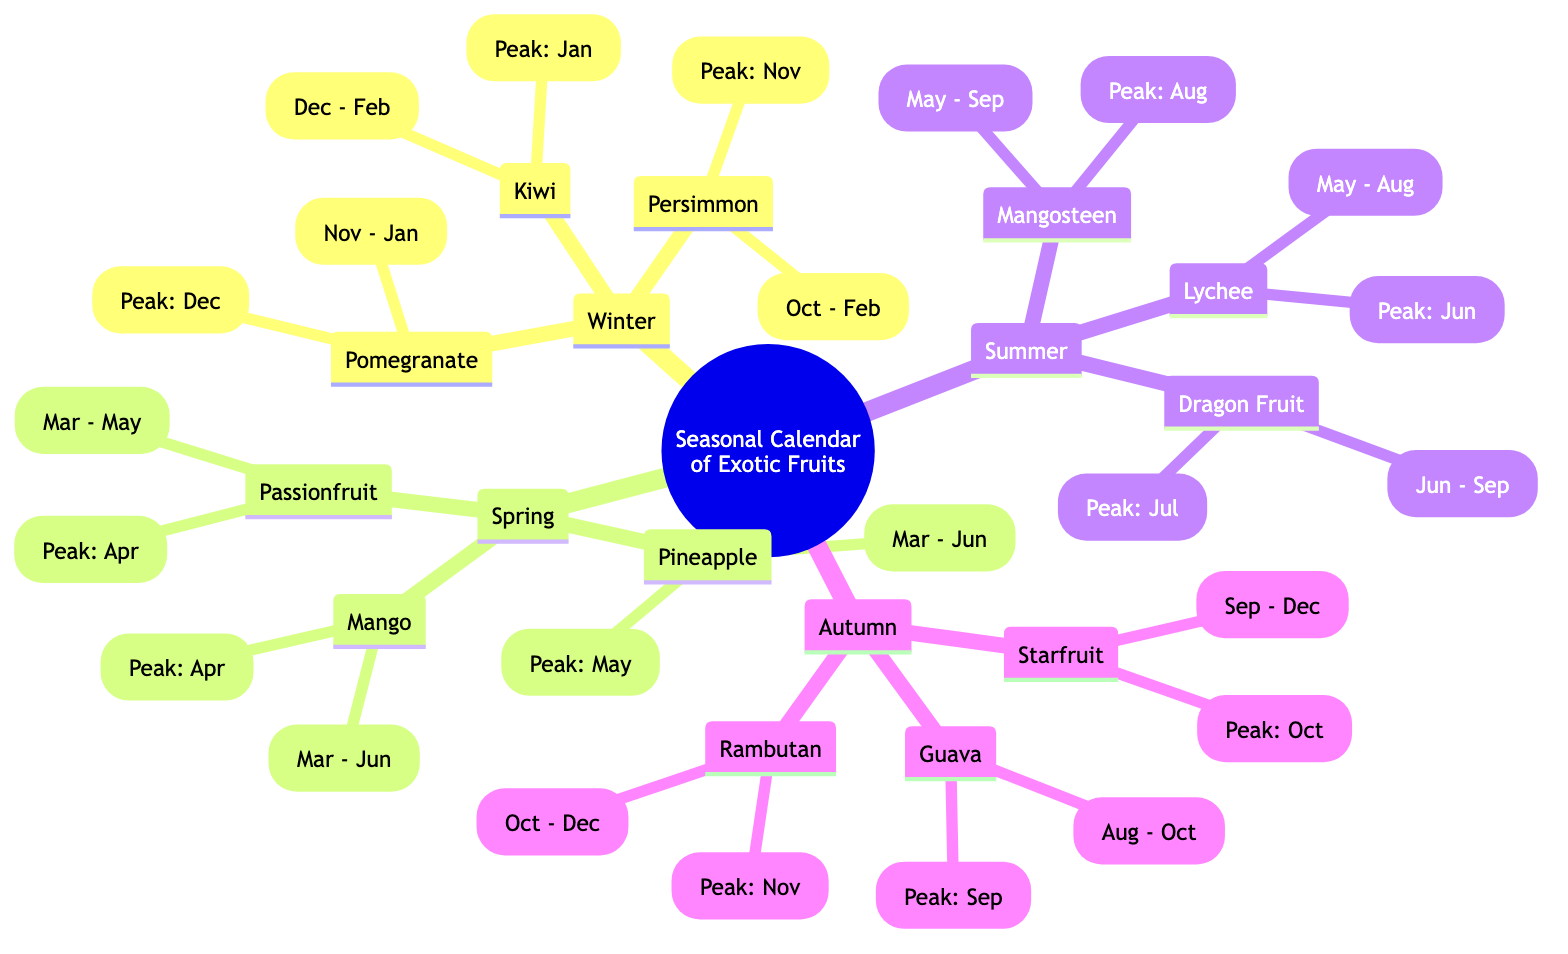What fruits are available in Winter? The diagram lists Kiwi, Pomegranate, and Persimmon as available in Winter, which is indicated under the Winter node in the fruit section.
Answer: Kiwi, Pomegranate, Persimmon What is the peak harvest time for Mango? According to the diagram, Mango’s peak harvest time is specified under the Spring section next to its availability. It shows April as the peak harvest time.
Answer: April Which fruit has the earliest peak harvest in the year? To determine this, we look across all the fruits’ peak harvest times. Kiwi’s peak harvest is in January, which is earlier than others.
Answer: January How many fruits are listed in the Autumn section? By counting the fruits listed under the Autumn node, we find that there are three fruits mentioned: Rambutan, Starfruit, and Guava.
Answer: 3 Which fruit has the longest availability period? We compare the availability periods of all fruits. Mangosteen is available from May to September, providing a duration of five months, the longest compared to others.
Answer: Mangosteen What is the peak harvest month for Dragon Fruit? Dragon Fruit’s peak harvest month can be found in the Summer section where it is mentioned as July next to its availability.
Answer: July Which season has the most fruits listed? By examining the number of fruits available in each seasonal section, we find that Summer has three fruits listed, matching Winter, Spring, and Autumn.
Answer: 3 What fruit is available in both Spring and Summer? The diagram shows Pineapple listed in Spring and doesn’t have any overlap with Summer, thus we see that this is the only fruit mentioned in Spring but not again in Summer.
Answer: Pineapple 